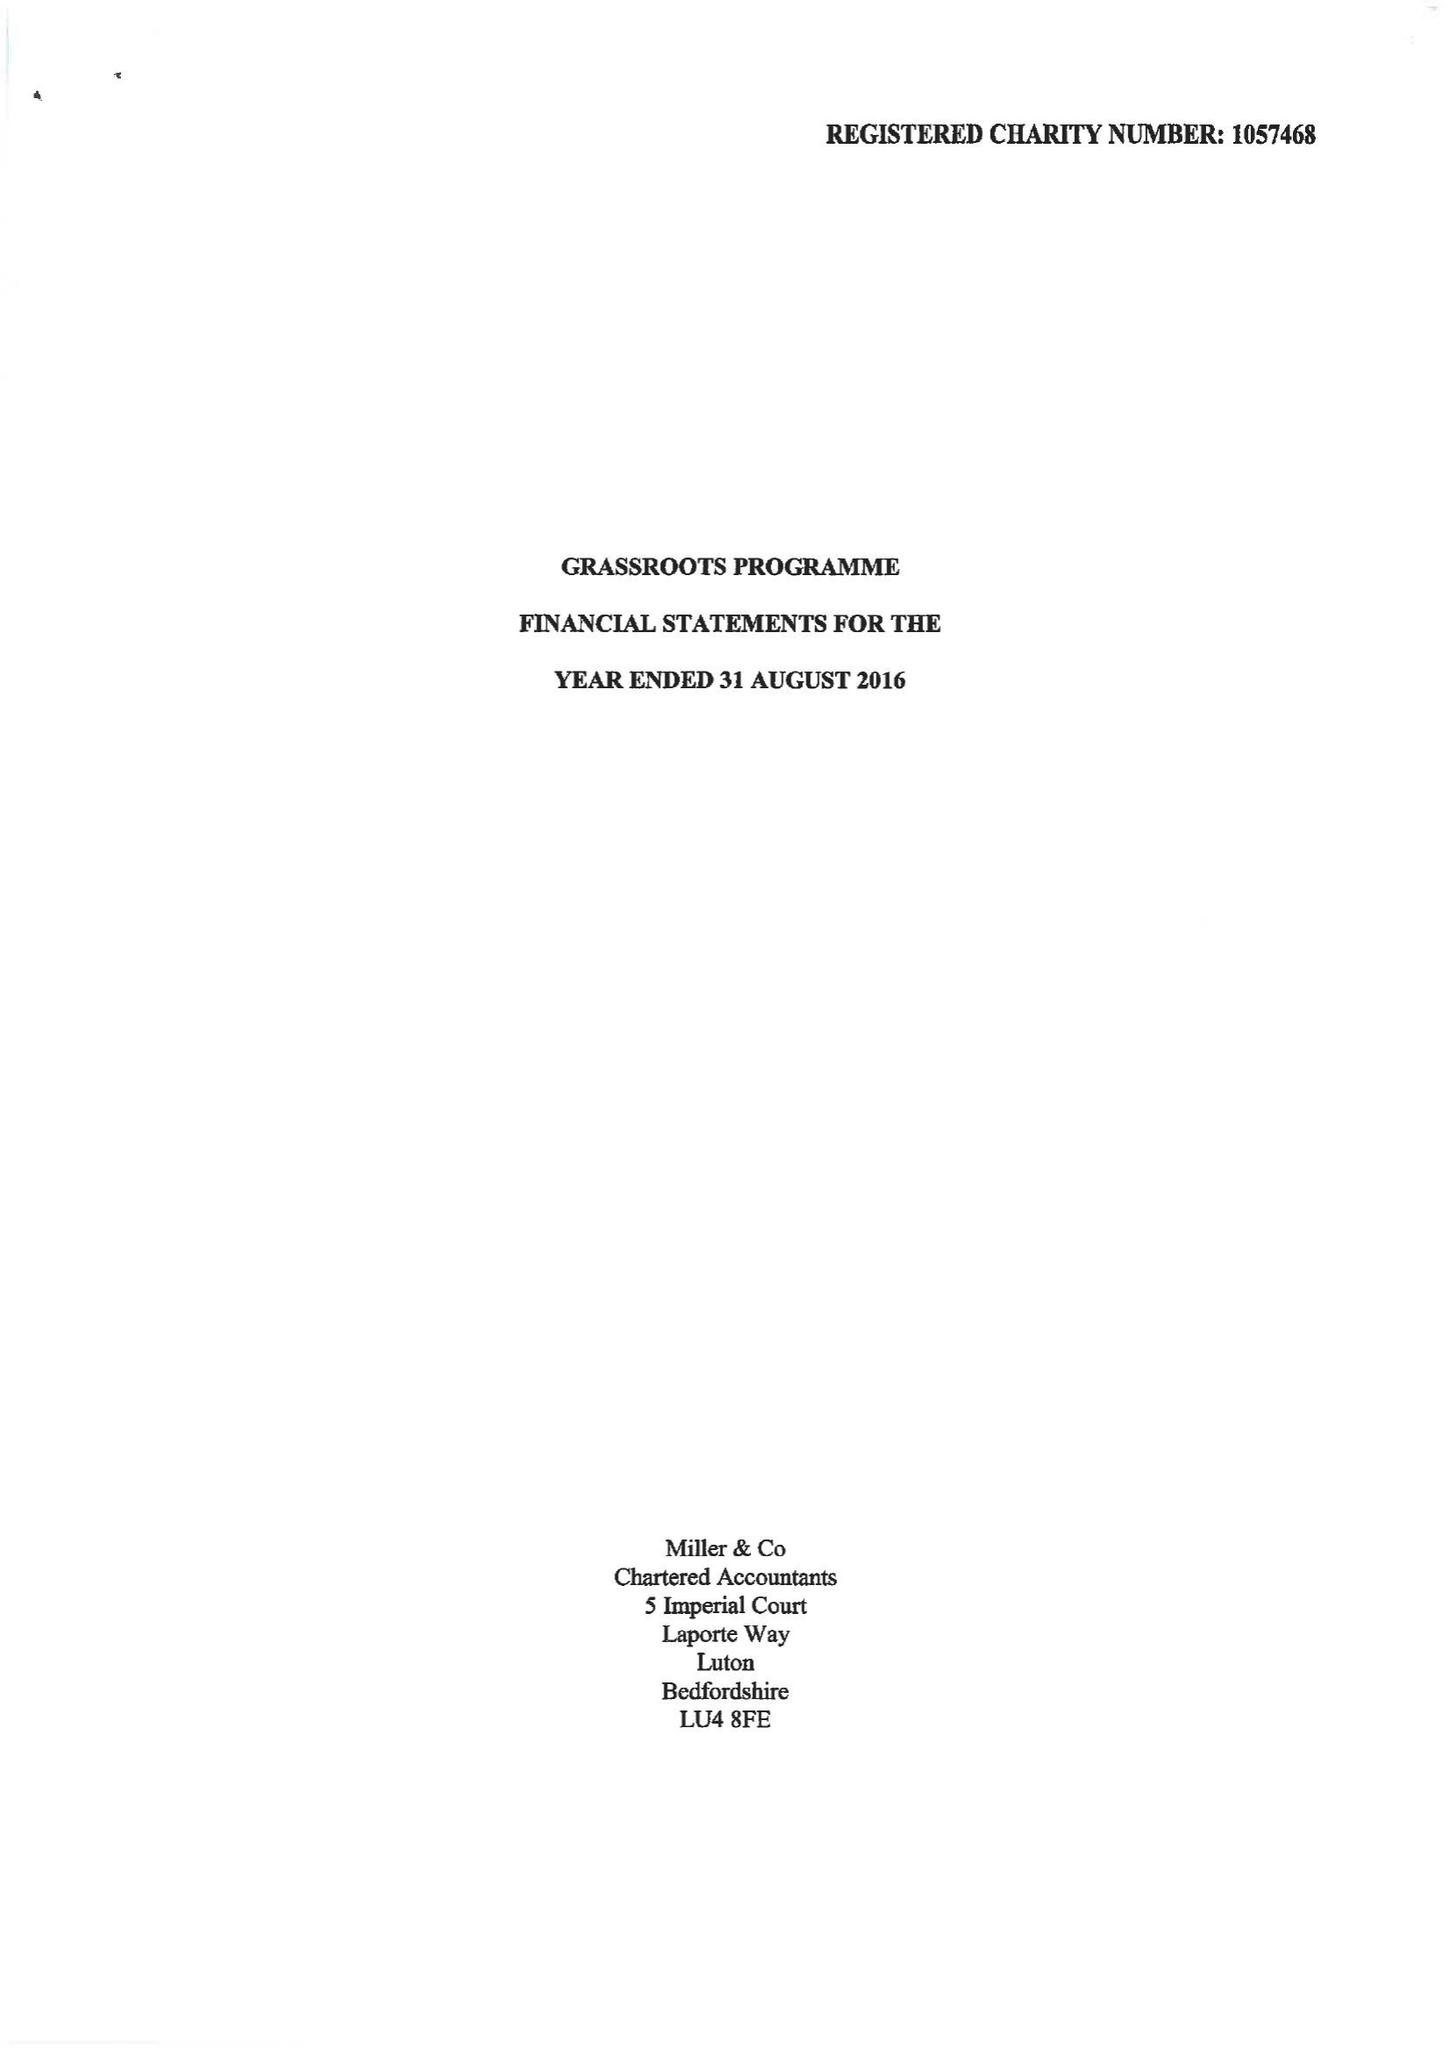What is the value for the address__street_line?
Answer the question using a single word or phrase. 47 HIGH TOWN ROAD 